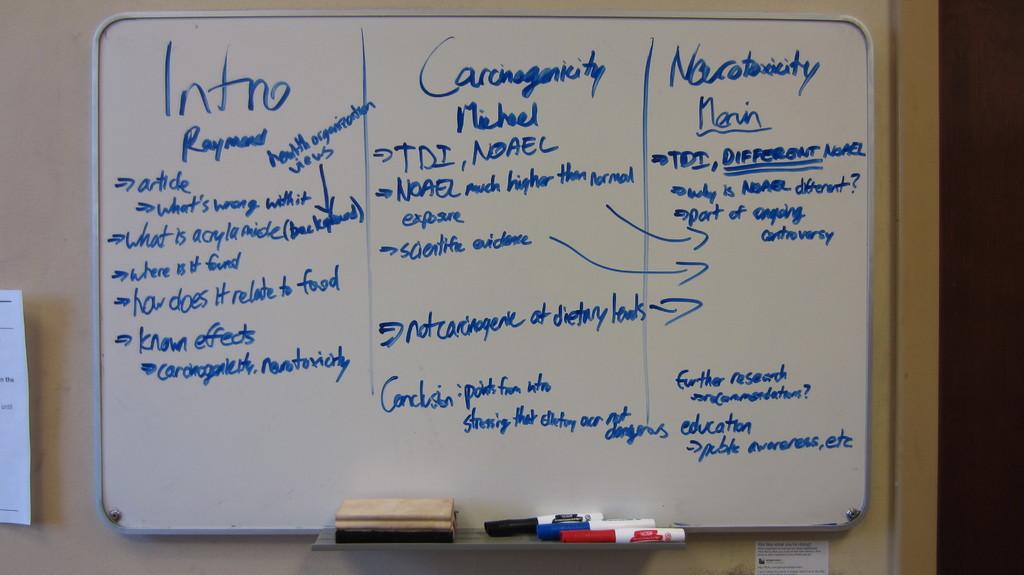What is the title of the first section on the white board?
Ensure brevity in your answer.  Intro. What is the title of the second section on the white board?
Give a very brief answer. Carcinogenicity . 